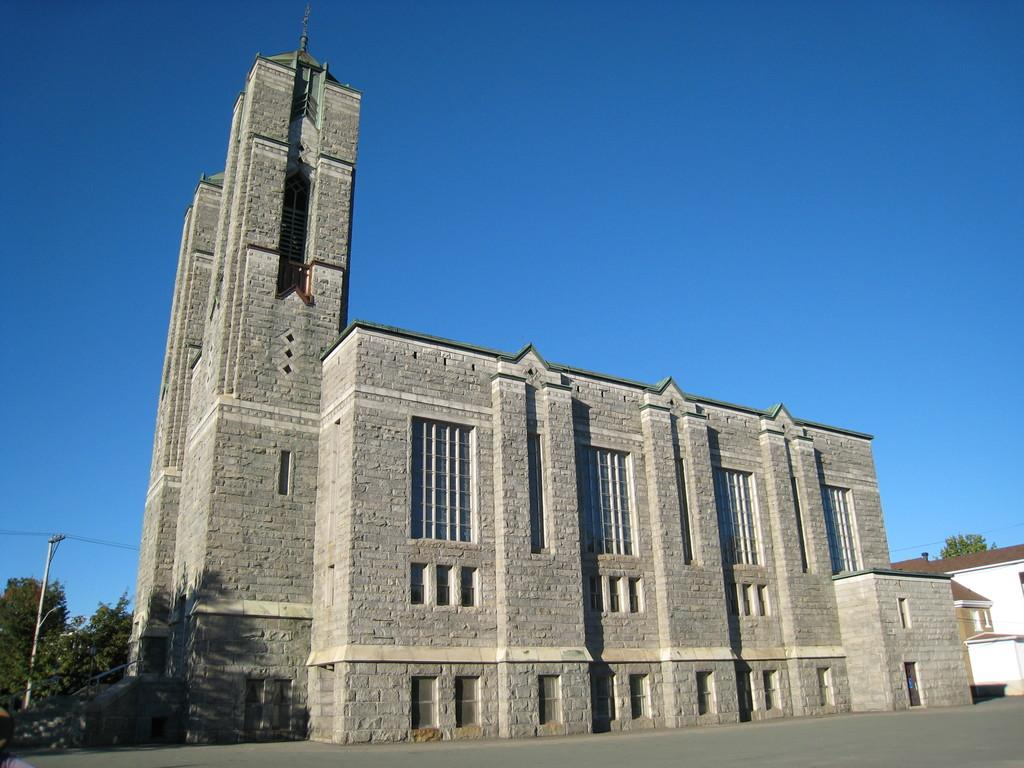What is located in the foreground of the image? There is a road in the foreground of the image. What can be seen in the middle of the image? There are buildings, trees, a pole, and cables in the middle of the image. What is visible at the top of the image? The sky is visible at the top of the image. How many fish can be seen swimming in the field in the image? There are no fish or fields present in the image; it features a road, buildings, trees, a pole, cables, and the sky. What type of attraction is located in the middle of the image? There is no attraction present in the image; it features a road, buildings, trees, a pole, cables, and the sky. 